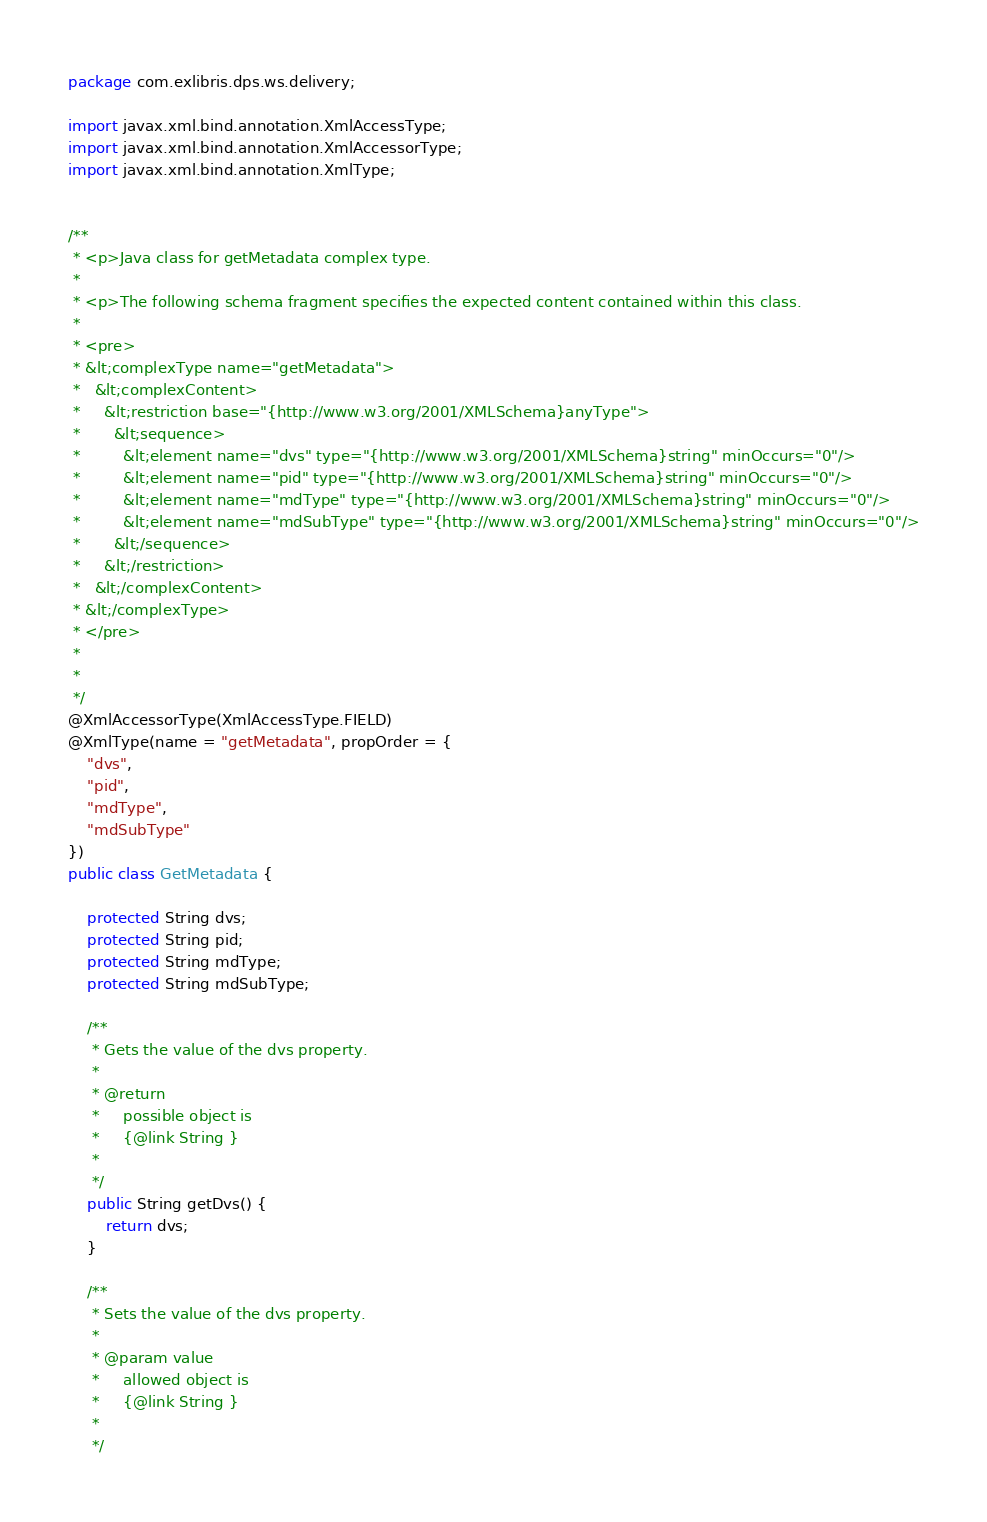<code> <loc_0><loc_0><loc_500><loc_500><_Java_>
package com.exlibris.dps.ws.delivery;

import javax.xml.bind.annotation.XmlAccessType;
import javax.xml.bind.annotation.XmlAccessorType;
import javax.xml.bind.annotation.XmlType;


/**
 * <p>Java class for getMetadata complex type.
 *
 * <p>The following schema fragment specifies the expected content contained within this class.
 *
 * <pre>
 * &lt;complexType name="getMetadata">
 *   &lt;complexContent>
 *     &lt;restriction base="{http://www.w3.org/2001/XMLSchema}anyType">
 *       &lt;sequence>
 *         &lt;element name="dvs" type="{http://www.w3.org/2001/XMLSchema}string" minOccurs="0"/>
 *         &lt;element name="pid" type="{http://www.w3.org/2001/XMLSchema}string" minOccurs="0"/>
 *         &lt;element name="mdType" type="{http://www.w3.org/2001/XMLSchema}string" minOccurs="0"/>
 *         &lt;element name="mdSubType" type="{http://www.w3.org/2001/XMLSchema}string" minOccurs="0"/>
 *       &lt;/sequence>
 *     &lt;/restriction>
 *   &lt;/complexContent>
 * &lt;/complexType>
 * </pre>
 *
 *
 */
@XmlAccessorType(XmlAccessType.FIELD)
@XmlType(name = "getMetadata", propOrder = {
    "dvs",
    "pid",
    "mdType",
    "mdSubType"
})
public class GetMetadata {

    protected String dvs;
    protected String pid;
    protected String mdType;
    protected String mdSubType;

    /**
     * Gets the value of the dvs property.
     *
     * @return
     *     possible object is
     *     {@link String }
     *
     */
    public String getDvs() {
        return dvs;
    }

    /**
     * Sets the value of the dvs property.
     *
     * @param value
     *     allowed object is
     *     {@link String }
     *
     */</code> 